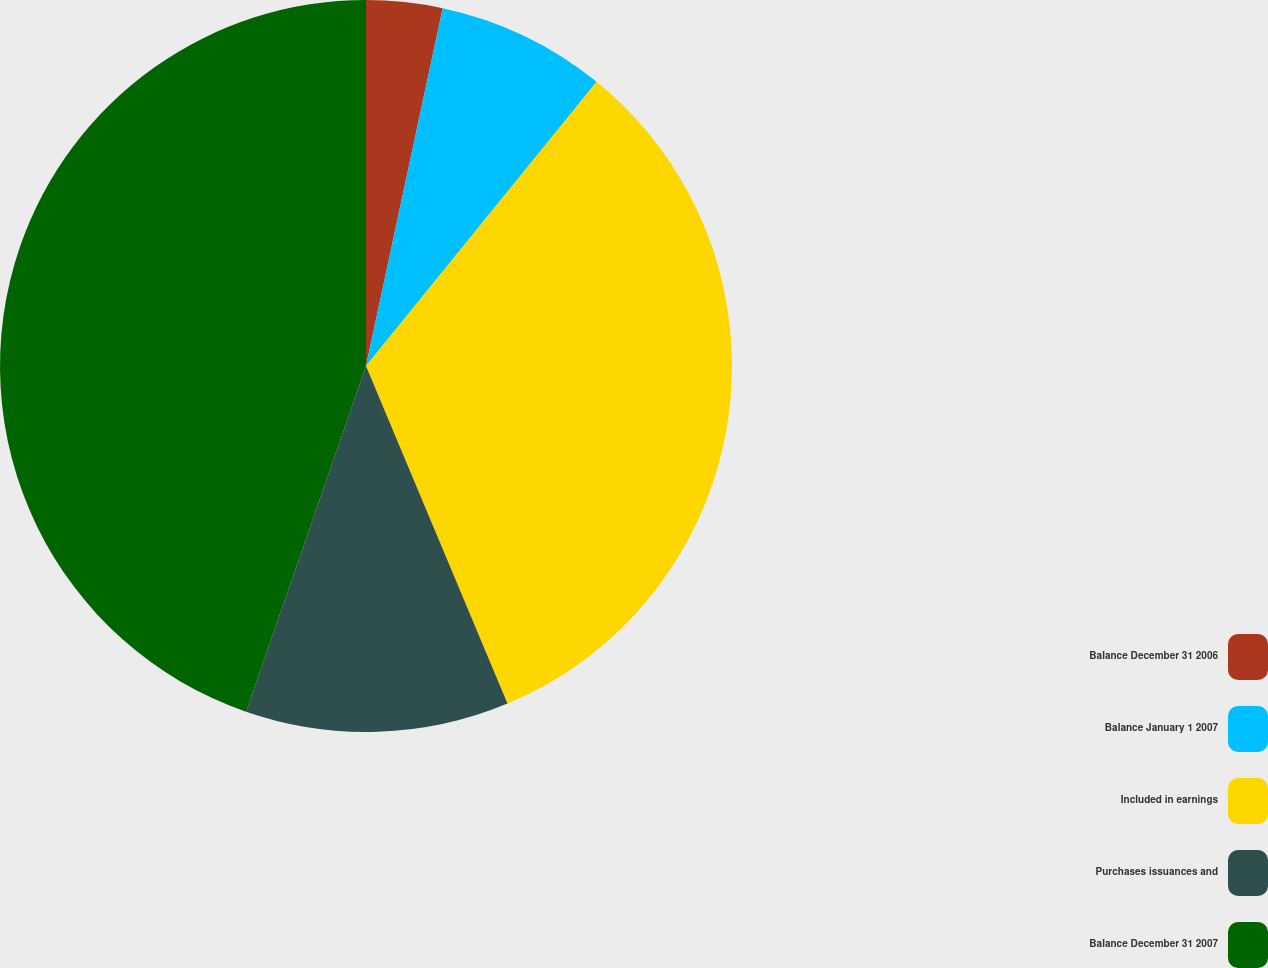<chart> <loc_0><loc_0><loc_500><loc_500><pie_chart><fcel>Balance December 31 2006<fcel>Balance January 1 2007<fcel>Included in earnings<fcel>Purchases issuances and<fcel>Balance December 31 2007<nl><fcel>3.36%<fcel>7.49%<fcel>32.83%<fcel>11.63%<fcel>44.68%<nl></chart> 